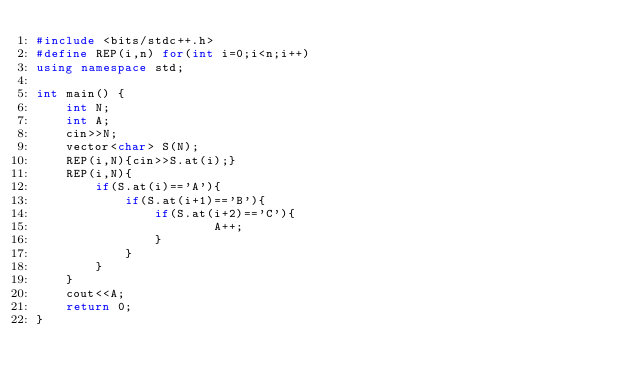<code> <loc_0><loc_0><loc_500><loc_500><_C++_>#include <bits/stdc++.h>
#define REP(i,n) for(int i=0;i<n;i++)
using namespace std;

int main() {
    int N;
    int A;
    cin>>N;
    vector<char> S(N);
    REP(i,N){cin>>S.at(i);}
    REP(i,N){
        if(S.at(i)=='A'){
            if(S.at(i+1)=='B'){
                if(S.at(i+2)=='C'){
                        A++;
                }
            }
        }
    }
    cout<<A;
    return 0;
}</code> 